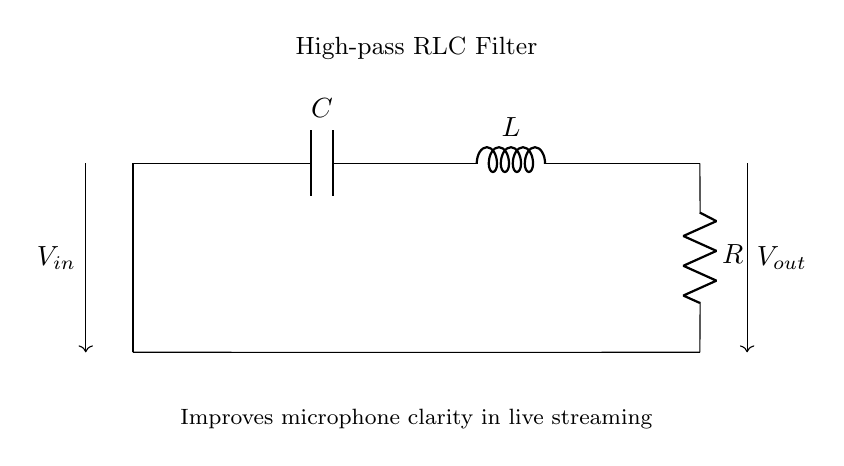What are the components of this circuit? The circuit consists of a capacitor, inductor, and resistor, as indicated by the labels C, L, and R.
Answer: Capacitor, inductor, resistor What is the input voltage labelled in the circuit? The input voltage is denoted as V_in, represented by the arrow entering the circuit from the left side.
Answer: V_in What is the role of the capacitor in this high-pass filter? The capacitor blocks low-frequency signals, allowing high-frequency signals to pass through to the output.
Answer: Blocks low-frequency signals What is connected between the inductor and the output? The resistor is connected between the inductor and the output, providing a discharge path for the energy in the circuit.
Answer: Resistor How does this RLC filter improve microphone clarity? It allows high-frequency audio signals to pass while attenuating unwanted low-frequency noise, resulting in clearer sound.
Answer: Attenuates low-frequency noise What type of filter is this circuit classified as? This circuit is classified as a high-pass filter, as it is designed to allow signals above a certain frequency to pass while blocking lower frequencies.
Answer: High-pass filter At what point does the output voltage occur? The output voltage is measured at the junction between the inductor and the resistor, indicated by V_out at the bottom-right of the circuit diagram.
Answer: At the junction of the inductor and resistor 